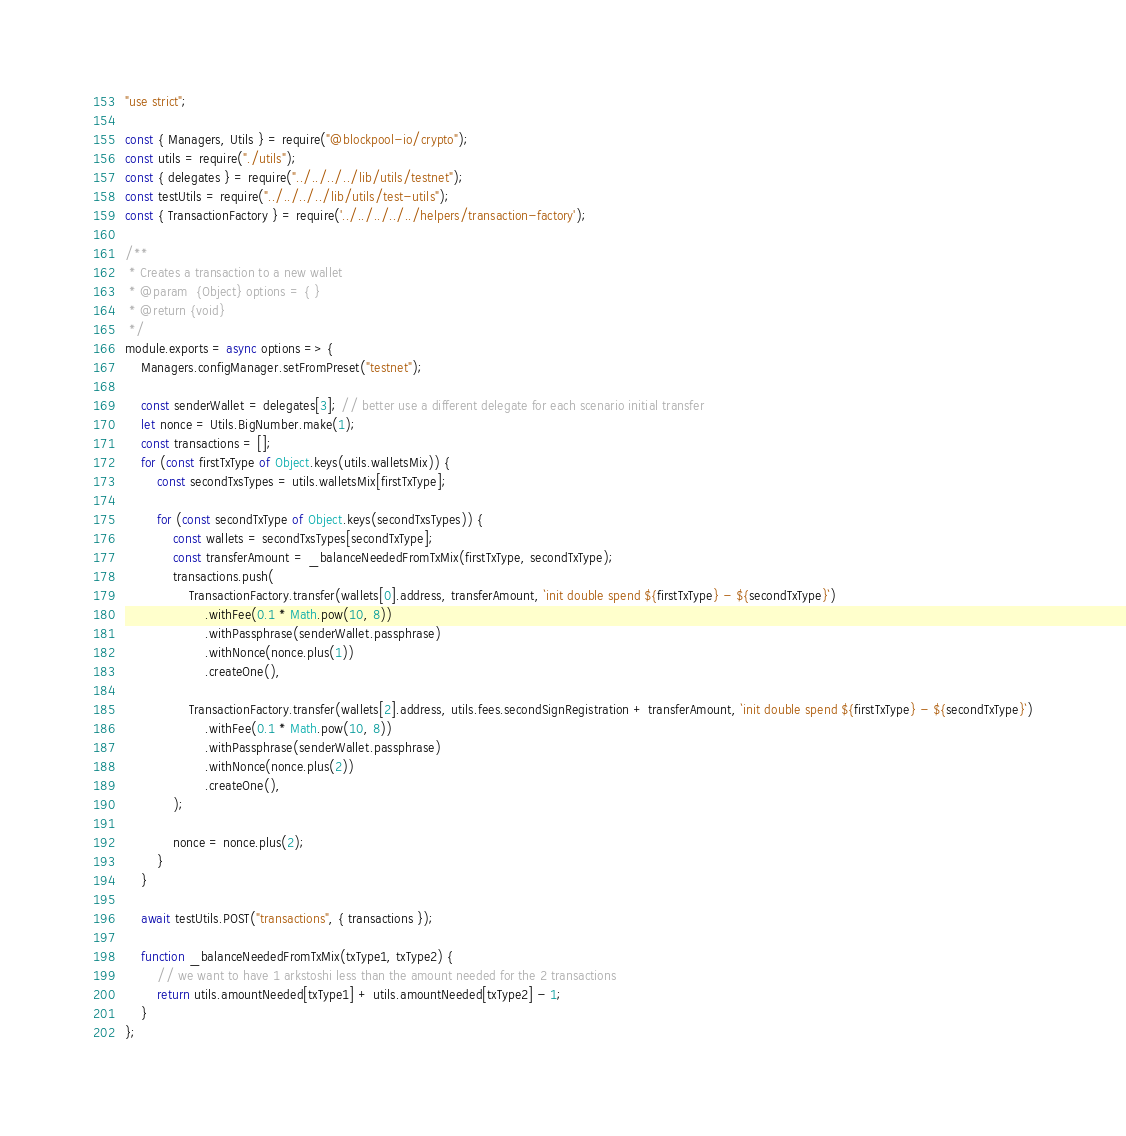Convert code to text. <code><loc_0><loc_0><loc_500><loc_500><_JavaScript_>"use strict";

const { Managers, Utils } = require("@blockpool-io/crypto");
const utils = require("./utils");
const { delegates } = require("../../../../lib/utils/testnet");
const testUtils = require("../../../../lib/utils/test-utils");
const { TransactionFactory } = require('../../../../../helpers/transaction-factory');

/**
 * Creates a transaction to a new wallet
 * @param  {Object} options = { }
 * @return {void}
 */
module.exports = async options => {
    Managers.configManager.setFromPreset("testnet");

    const senderWallet = delegates[3]; // better use a different delegate for each scenario initial transfer
    let nonce = Utils.BigNumber.make(1);
    const transactions = [];
    for (const firstTxType of Object.keys(utils.walletsMix)) {
        const secondTxsTypes = utils.walletsMix[firstTxType];

        for (const secondTxType of Object.keys(secondTxsTypes)) {
            const wallets = secondTxsTypes[secondTxType];
            const transferAmount = _balanceNeededFromTxMix(firstTxType, secondTxType);
            transactions.push(
                TransactionFactory.transfer(wallets[0].address, transferAmount, `init double spend ${firstTxType} - ${secondTxType}`)
                    .withFee(0.1 * Math.pow(10, 8))
                    .withPassphrase(senderWallet.passphrase)
                    .withNonce(nonce.plus(1))
                    .createOne(),

                TransactionFactory.transfer(wallets[2].address, utils.fees.secondSignRegistration + transferAmount, `init double spend ${firstTxType} - ${secondTxType}`)
                    .withFee(0.1 * Math.pow(10, 8))
                    .withPassphrase(senderWallet.passphrase)
                    .withNonce(nonce.plus(2))
                    .createOne(),
            );

            nonce = nonce.plus(2);
        }
    }

    await testUtils.POST("transactions", { transactions });

    function _balanceNeededFromTxMix(txType1, txType2) {
        // we want to have 1 arkstoshi less than the amount needed for the 2 transactions
        return utils.amountNeeded[txType1] + utils.amountNeeded[txType2] - 1;
    }
};
</code> 